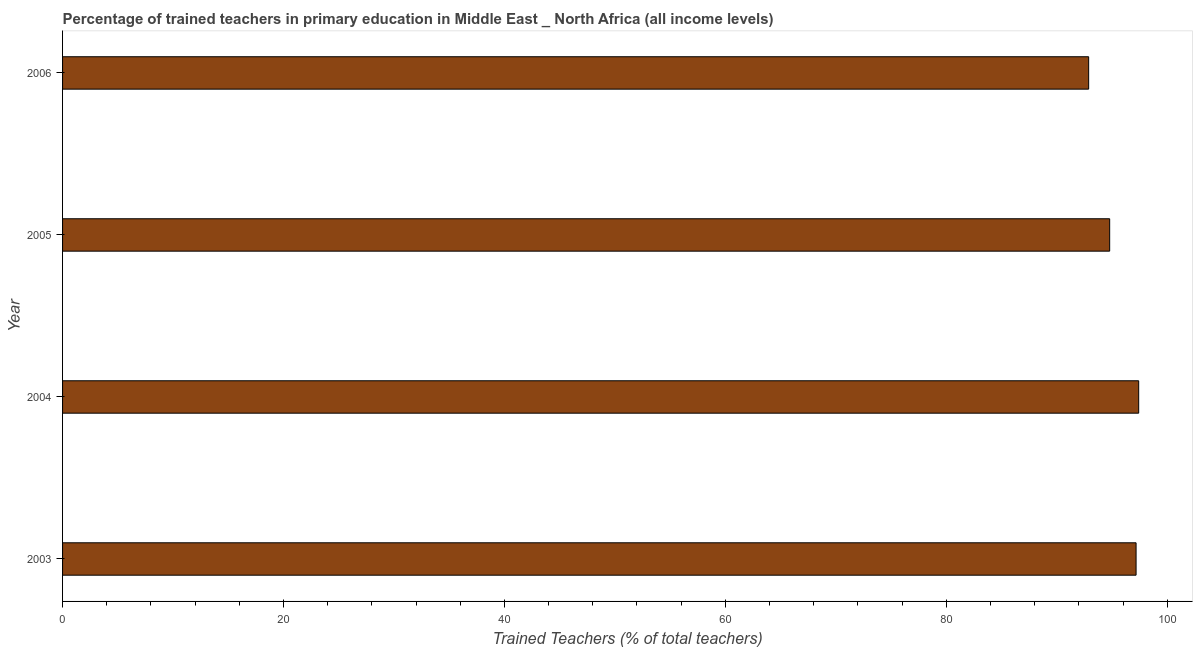Does the graph contain grids?
Ensure brevity in your answer.  No. What is the title of the graph?
Make the answer very short. Percentage of trained teachers in primary education in Middle East _ North Africa (all income levels). What is the label or title of the X-axis?
Give a very brief answer. Trained Teachers (% of total teachers). What is the percentage of trained teachers in 2005?
Provide a short and direct response. 94.79. Across all years, what is the maximum percentage of trained teachers?
Your answer should be compact. 97.42. Across all years, what is the minimum percentage of trained teachers?
Offer a terse response. 92.89. In which year was the percentage of trained teachers maximum?
Keep it short and to the point. 2004. What is the sum of the percentage of trained teachers?
Offer a terse response. 382.29. What is the difference between the percentage of trained teachers in 2004 and 2005?
Keep it short and to the point. 2.63. What is the average percentage of trained teachers per year?
Provide a short and direct response. 95.57. What is the median percentage of trained teachers?
Ensure brevity in your answer.  95.99. In how many years, is the percentage of trained teachers greater than 52 %?
Make the answer very short. 4. What is the ratio of the percentage of trained teachers in 2004 to that in 2005?
Ensure brevity in your answer.  1.03. Is the difference between the percentage of trained teachers in 2003 and 2004 greater than the difference between any two years?
Provide a succinct answer. No. What is the difference between the highest and the second highest percentage of trained teachers?
Give a very brief answer. 0.23. Is the sum of the percentage of trained teachers in 2003 and 2006 greater than the maximum percentage of trained teachers across all years?
Offer a very short reply. Yes. What is the difference between the highest and the lowest percentage of trained teachers?
Provide a short and direct response. 4.53. In how many years, is the percentage of trained teachers greater than the average percentage of trained teachers taken over all years?
Offer a very short reply. 2. How many bars are there?
Provide a short and direct response. 4. What is the difference between two consecutive major ticks on the X-axis?
Offer a very short reply. 20. Are the values on the major ticks of X-axis written in scientific E-notation?
Make the answer very short. No. What is the Trained Teachers (% of total teachers) in 2003?
Provide a short and direct response. 97.18. What is the Trained Teachers (% of total teachers) in 2004?
Your answer should be very brief. 97.42. What is the Trained Teachers (% of total teachers) in 2005?
Give a very brief answer. 94.79. What is the Trained Teachers (% of total teachers) in 2006?
Your answer should be compact. 92.89. What is the difference between the Trained Teachers (% of total teachers) in 2003 and 2004?
Offer a terse response. -0.24. What is the difference between the Trained Teachers (% of total teachers) in 2003 and 2005?
Provide a short and direct response. 2.39. What is the difference between the Trained Teachers (% of total teachers) in 2003 and 2006?
Your answer should be very brief. 4.29. What is the difference between the Trained Teachers (% of total teachers) in 2004 and 2005?
Your answer should be very brief. 2.63. What is the difference between the Trained Teachers (% of total teachers) in 2004 and 2006?
Provide a short and direct response. 4.53. What is the difference between the Trained Teachers (% of total teachers) in 2005 and 2006?
Provide a succinct answer. 1.9. What is the ratio of the Trained Teachers (% of total teachers) in 2003 to that in 2006?
Ensure brevity in your answer.  1.05. What is the ratio of the Trained Teachers (% of total teachers) in 2004 to that in 2005?
Offer a very short reply. 1.03. What is the ratio of the Trained Teachers (% of total teachers) in 2004 to that in 2006?
Give a very brief answer. 1.05. 